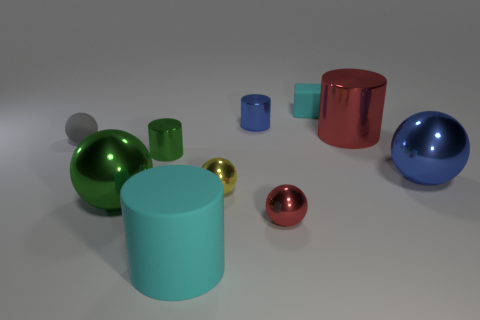What might be the function of these various objects if they were used in everyday life? If these objects were utilized in everyday life, their functions could be quite diverse. The cylinders might serve as containers or stands, perhaps for holding writing utensils or as minimalist decorative vases. The spheres could be ornamental, serving as paperweights or part of kinetic sculptures, and the cube might also function as a stylish paperweight or as a block for design and architectural purposes. The combination of shapes and finishes could be useful for educational purposes, too, such as teaching geometry or illustrating principles of light reflection and material properties. 